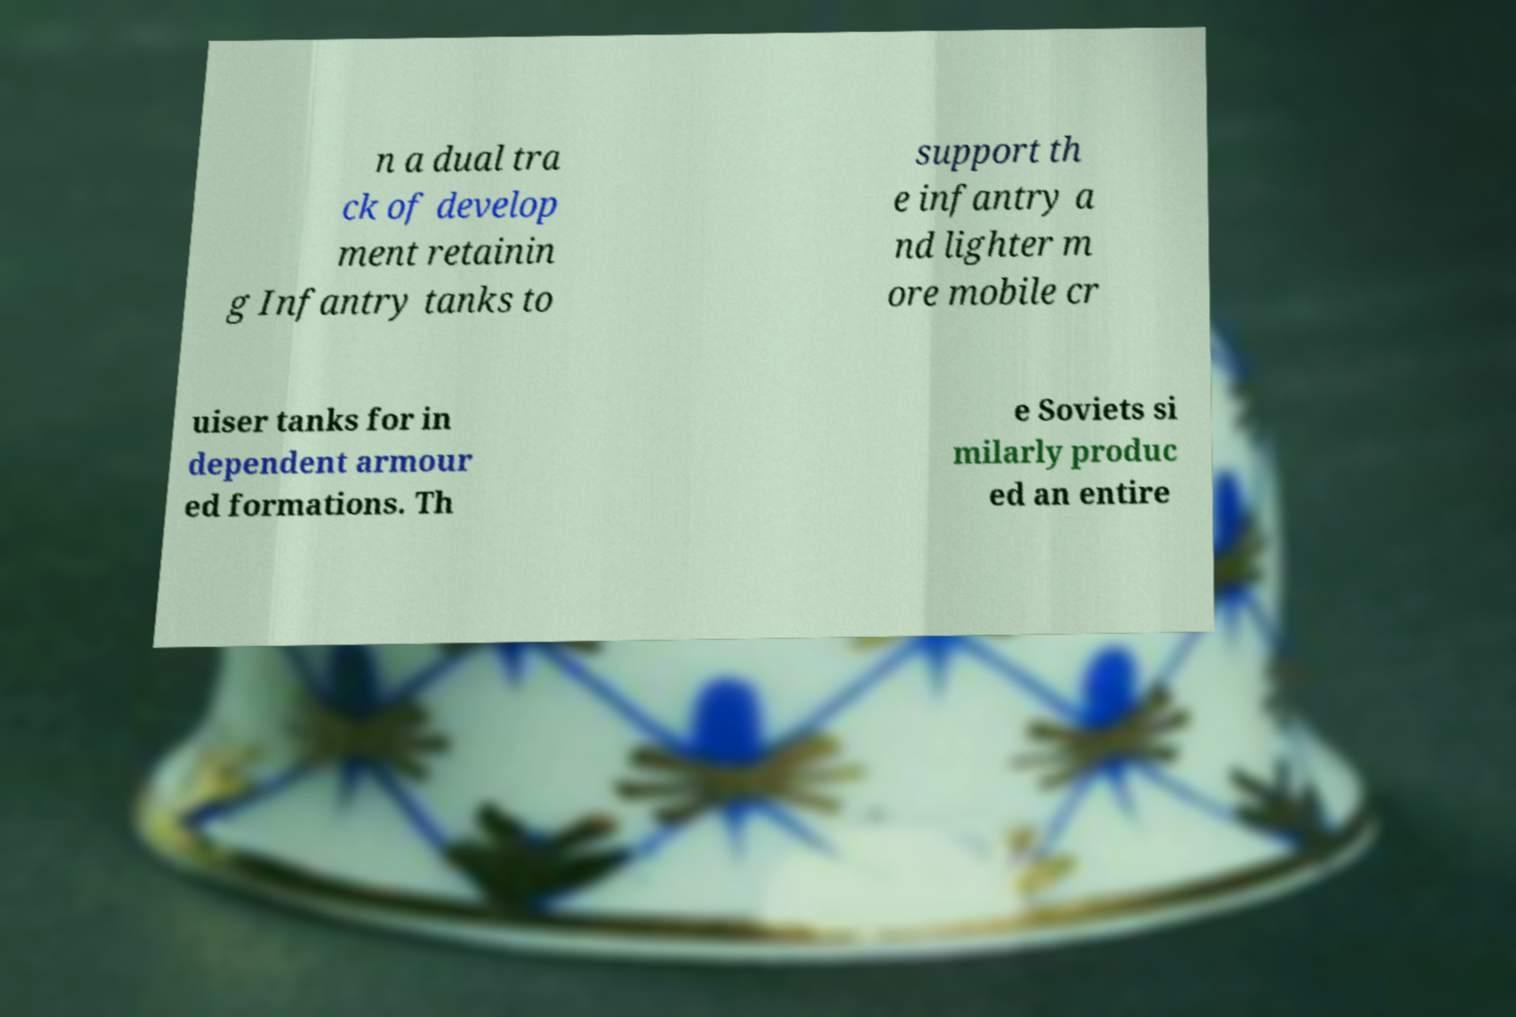There's text embedded in this image that I need extracted. Can you transcribe it verbatim? n a dual tra ck of develop ment retainin g Infantry tanks to support th e infantry a nd lighter m ore mobile cr uiser tanks for in dependent armour ed formations. Th e Soviets si milarly produc ed an entire 